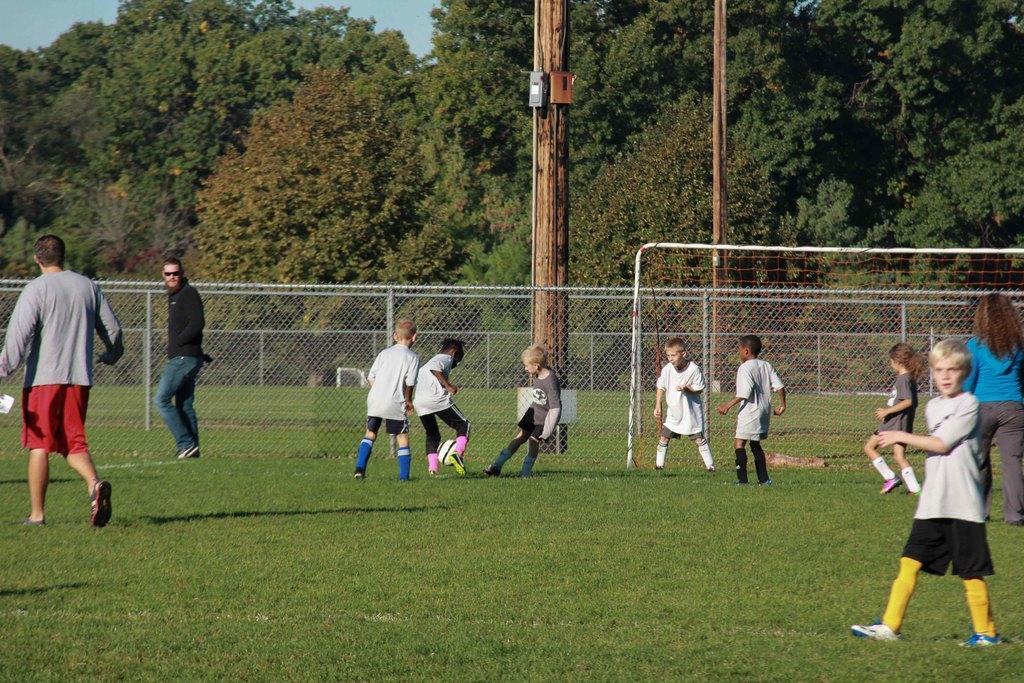Please provide a concise description of this image. This is a picture of a football ground. In the foreground of the picture there are kids, men and women playing football. In the center of the picture there are fencing and poles. In the background there are trees. Sky is clear and it is sunny. 